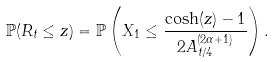<formula> <loc_0><loc_0><loc_500><loc_500>\mathbb { P } ( R _ { t } \leq z ) = \mathbb { P } \left ( X _ { 1 } \leq \frac { \cosh ( z ) - 1 } { 2 A _ { t / 4 } ^ { ( 2 \alpha + 1 ) } } \right ) .</formula> 